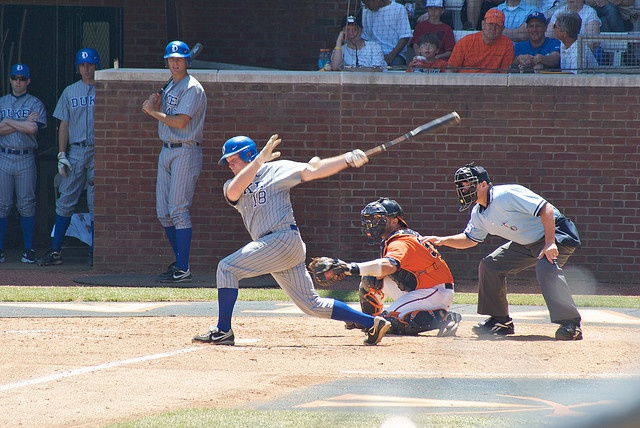Describe the objects in this image and their specific colors. I can see people in black, darkgray, white, navy, and tan tones, people in black, gray, darkgray, and white tones, people in black, gray, and navy tones, people in black, red, and gray tones, and people in black, darkblue, navy, and gray tones in this image. 